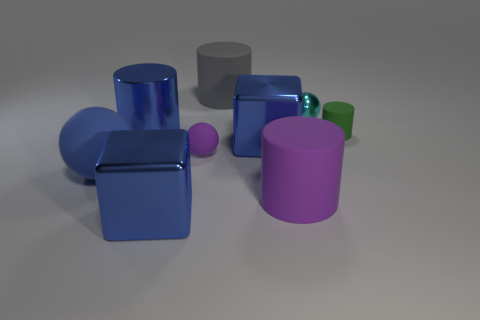Do the large rubber cylinder that is in front of the big gray cylinder and the small rubber ball have the same color?
Keep it short and to the point. Yes. There is a blue shiny thing in front of the rubber thing that is to the left of the big metal cylinder; how big is it?
Offer a very short reply. Large. Is the number of cylinders that are on the left side of the purple cylinder greater than the number of large brown shiny cylinders?
Provide a succinct answer. Yes. Do the purple matte object in front of the purple ball and the tiny cylinder have the same size?
Your answer should be very brief. No. What is the color of the rubber cylinder that is on the left side of the small cyan object and in front of the big gray matte cylinder?
Give a very brief answer. Purple. What shape is the green object that is the same size as the purple sphere?
Offer a very short reply. Cylinder. Is there a small ball that has the same color as the tiny shiny object?
Your response must be concise. No. Are there an equal number of shiny cylinders that are behind the blue metal cylinder and small green shiny cylinders?
Provide a succinct answer. Yes. Do the tiny matte cylinder and the shiny cylinder have the same color?
Your response must be concise. No. There is a cylinder that is both in front of the cyan metallic ball and to the left of the big purple cylinder; what size is it?
Give a very brief answer. Large. 